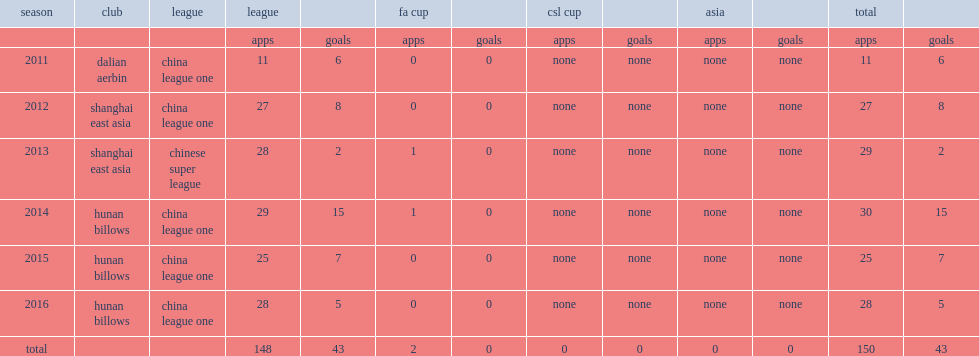In 2014, which league in china did cabezas transfer to? China league one. 